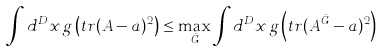Convert formula to latex. <formula><loc_0><loc_0><loc_500><loc_500>\int d ^ { D } x \, g \left ( t r ( A - a ) ^ { 2 } \right ) \leq \max _ { \bar { G } } \int d ^ { D } x \, g \left ( t r ( A ^ { \bar { G } } - a ) ^ { 2 } \right )</formula> 